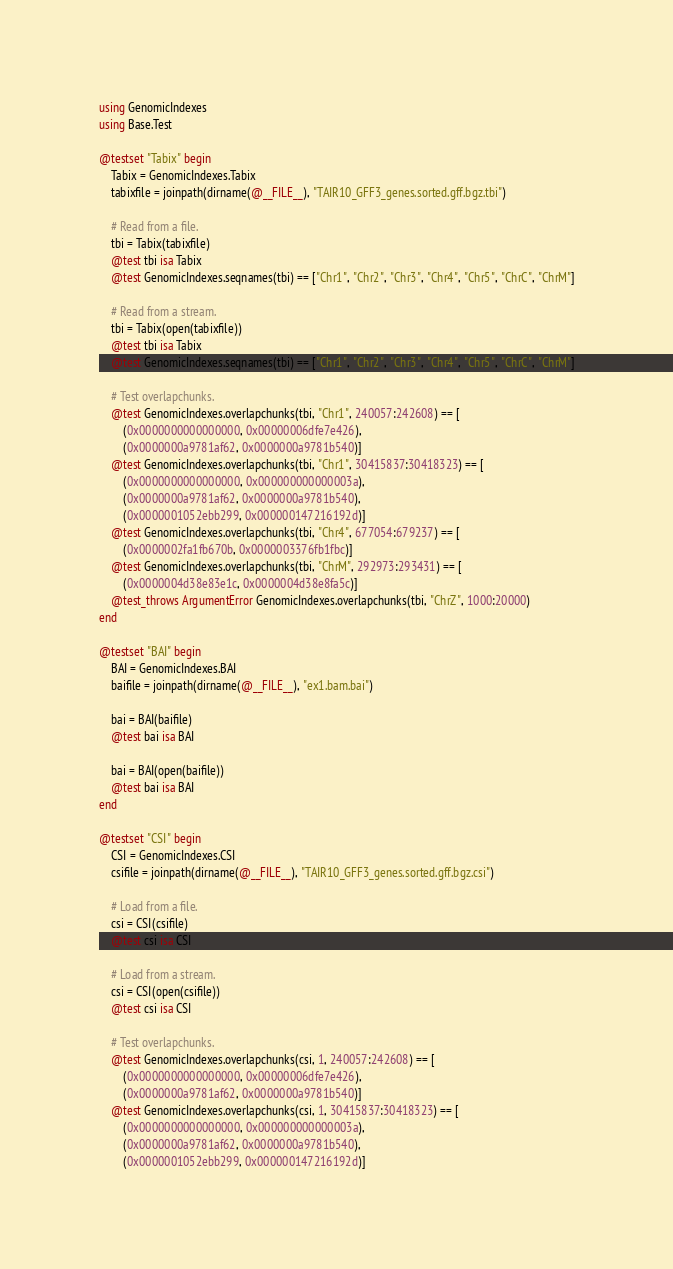<code> <loc_0><loc_0><loc_500><loc_500><_Julia_>using GenomicIndexes
using Base.Test

@testset "Tabix" begin
    Tabix = GenomicIndexes.Tabix
    tabixfile = joinpath(dirname(@__FILE__), "TAIR10_GFF3_genes.sorted.gff.bgz.tbi")

    # Read from a file.
    tbi = Tabix(tabixfile)
    @test tbi isa Tabix
    @test GenomicIndexes.seqnames(tbi) == ["Chr1", "Chr2", "Chr3", "Chr4", "Chr5", "ChrC", "ChrM"]

    # Read from a stream.
    tbi = Tabix(open(tabixfile))
    @test tbi isa Tabix
    @test GenomicIndexes.seqnames(tbi) == ["Chr1", "Chr2", "Chr3", "Chr4", "Chr5", "ChrC", "ChrM"]

    # Test overlapchunks.
    @test GenomicIndexes.overlapchunks(tbi, "Chr1", 240057:242608) == [
        (0x0000000000000000, 0x00000006dfe7e426),
        (0x0000000a9781af62, 0x0000000a9781b540)]
    @test GenomicIndexes.overlapchunks(tbi, "Chr1", 30415837:30418323) == [
        (0x0000000000000000, 0x000000000000003a),
        (0x0000000a9781af62, 0x0000000a9781b540),
        (0x0000001052ebb299, 0x000000147216192d)]
    @test GenomicIndexes.overlapchunks(tbi, "Chr4", 677054:679237) == [
        (0x0000002fa1fb670b, 0x0000003376fb1fbc)]
    @test GenomicIndexes.overlapchunks(tbi, "ChrM", 292973:293431) == [
        (0x0000004d38e83e1c, 0x0000004d38e8fa5c)]
    @test_throws ArgumentError GenomicIndexes.overlapchunks(tbi, "ChrZ", 1000:20000)
end

@testset "BAI" begin
    BAI = GenomicIndexes.BAI
    baifile = joinpath(dirname(@__FILE__), "ex1.bam.bai")

    bai = BAI(baifile)
    @test bai isa BAI

    bai = BAI(open(baifile))
    @test bai isa BAI
end

@testset "CSI" begin
    CSI = GenomicIndexes.CSI
    csifile = joinpath(dirname(@__FILE__), "TAIR10_GFF3_genes.sorted.gff.bgz.csi")

    # Load from a file.
    csi = CSI(csifile)
    @test csi isa CSI

    # Load from a stream.
    csi = CSI(open(csifile))
    @test csi isa CSI

    # Test overlapchunks.
    @test GenomicIndexes.overlapchunks(csi, 1, 240057:242608) == [
        (0x0000000000000000, 0x00000006dfe7e426),
        (0x0000000a9781af62, 0x0000000a9781b540)]
    @test GenomicIndexes.overlapchunks(csi, 1, 30415837:30418323) == [
        (0x0000000000000000, 0x000000000000003a),
        (0x0000000a9781af62, 0x0000000a9781b540),
        (0x0000001052ebb299, 0x000000147216192d)]</code> 